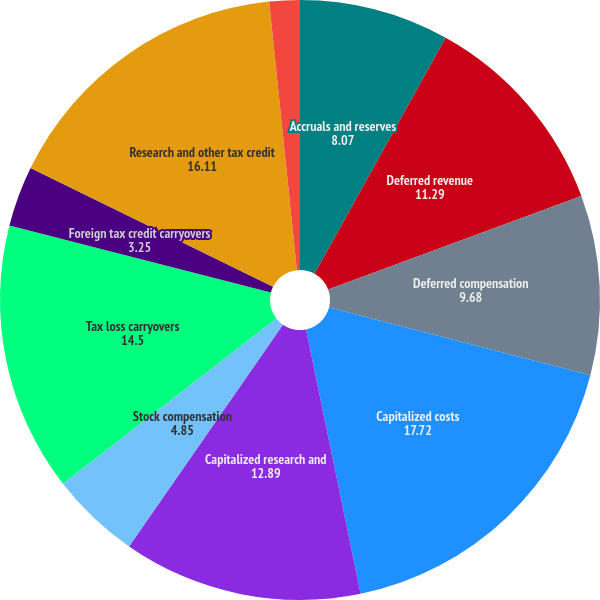Convert chart to OTSL. <chart><loc_0><loc_0><loc_500><loc_500><pie_chart><fcel>Accruals and reserves<fcel>Deferred revenue<fcel>Deferred compensation<fcel>Capitalized costs<fcel>Capitalized research and<fcel>Stock compensation<fcel>Tax loss carryovers<fcel>Foreign tax credit carryovers<fcel>Research and other tax credit<fcel>Other<nl><fcel>8.07%<fcel>11.29%<fcel>9.68%<fcel>17.72%<fcel>12.89%<fcel>4.85%<fcel>14.5%<fcel>3.25%<fcel>16.11%<fcel>1.64%<nl></chart> 